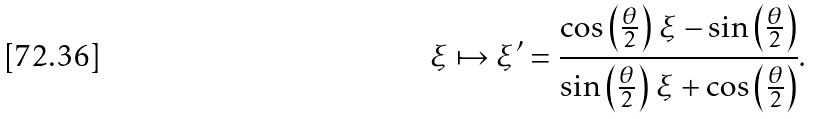Convert formula to latex. <formula><loc_0><loc_0><loc_500><loc_500>\xi \mapsto \xi ^ { \prime } = { \frac { \cos \left ( { \frac { \theta } { 2 } } \right ) \, \xi - \sin \left ( { \frac { \theta } { 2 } } \right ) } { \sin \left ( { \frac { \theta } { 2 } } \right ) \, \xi + \cos \left ( { \frac { \theta } { 2 } } \right ) } } .</formula> 